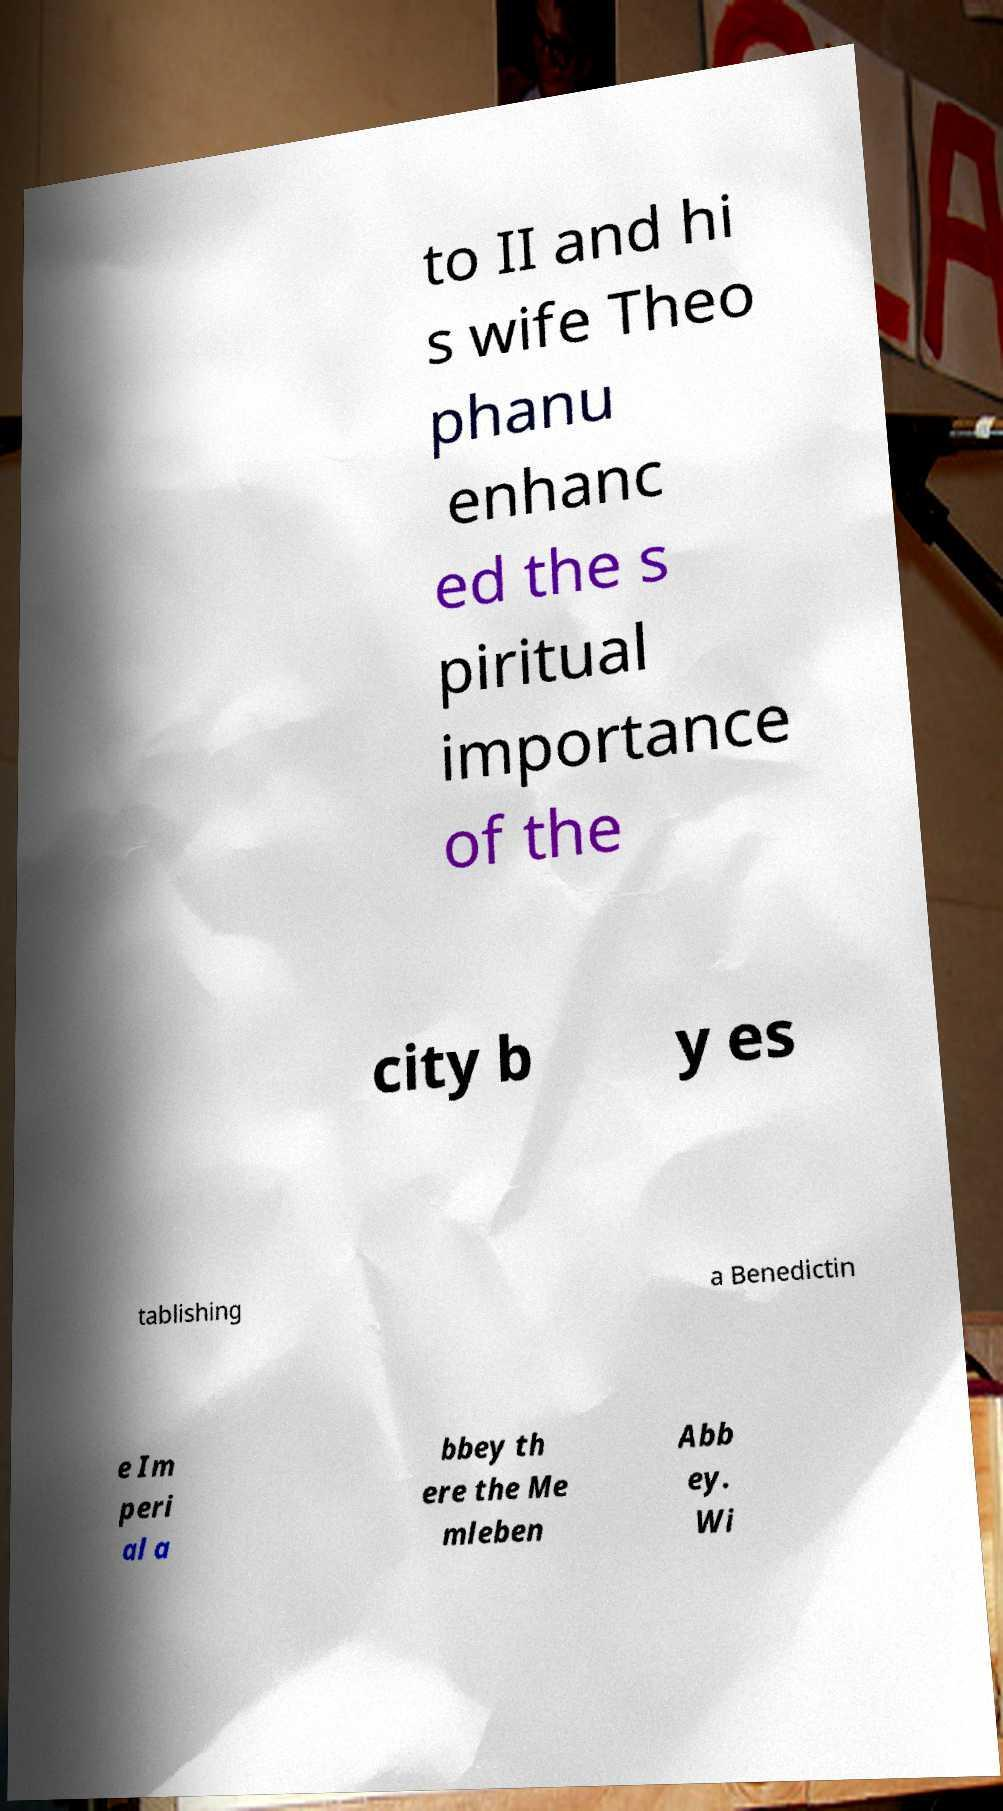Could you extract and type out the text from this image? to II and hi s wife Theo phanu enhanc ed the s piritual importance of the city b y es tablishing a Benedictin e Im peri al a bbey th ere the Me mleben Abb ey. Wi 